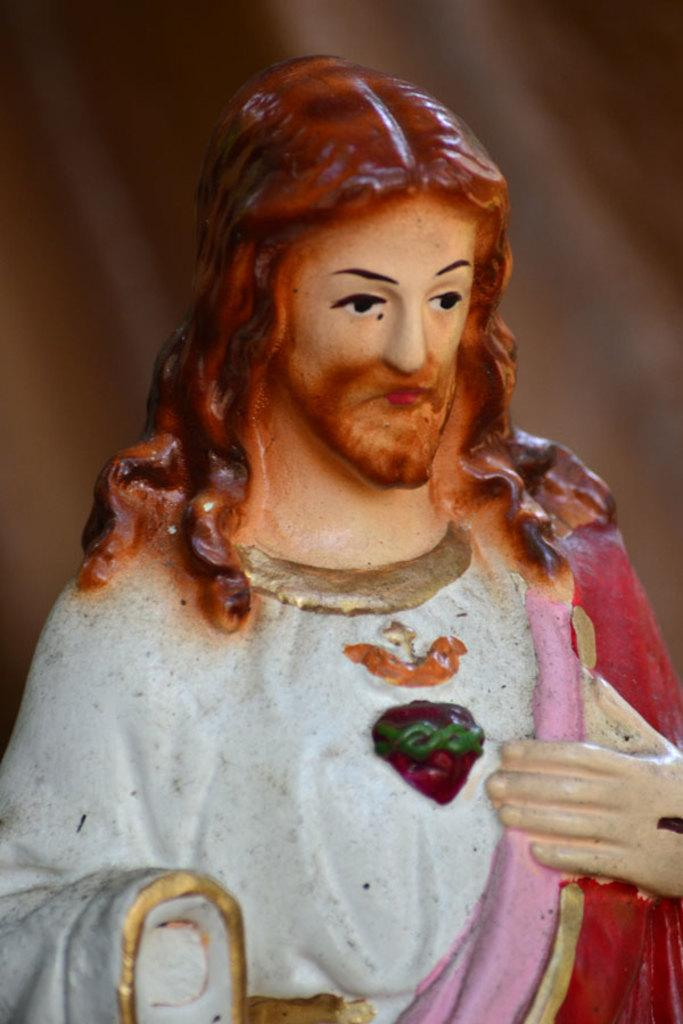Who is the main subject of the image? The main subject of the image is Jesus Christ. What type of coal is being used to heat the stove in the image? There is no stove or coal present in the image; it contains a depiction of Jesus Christ. 